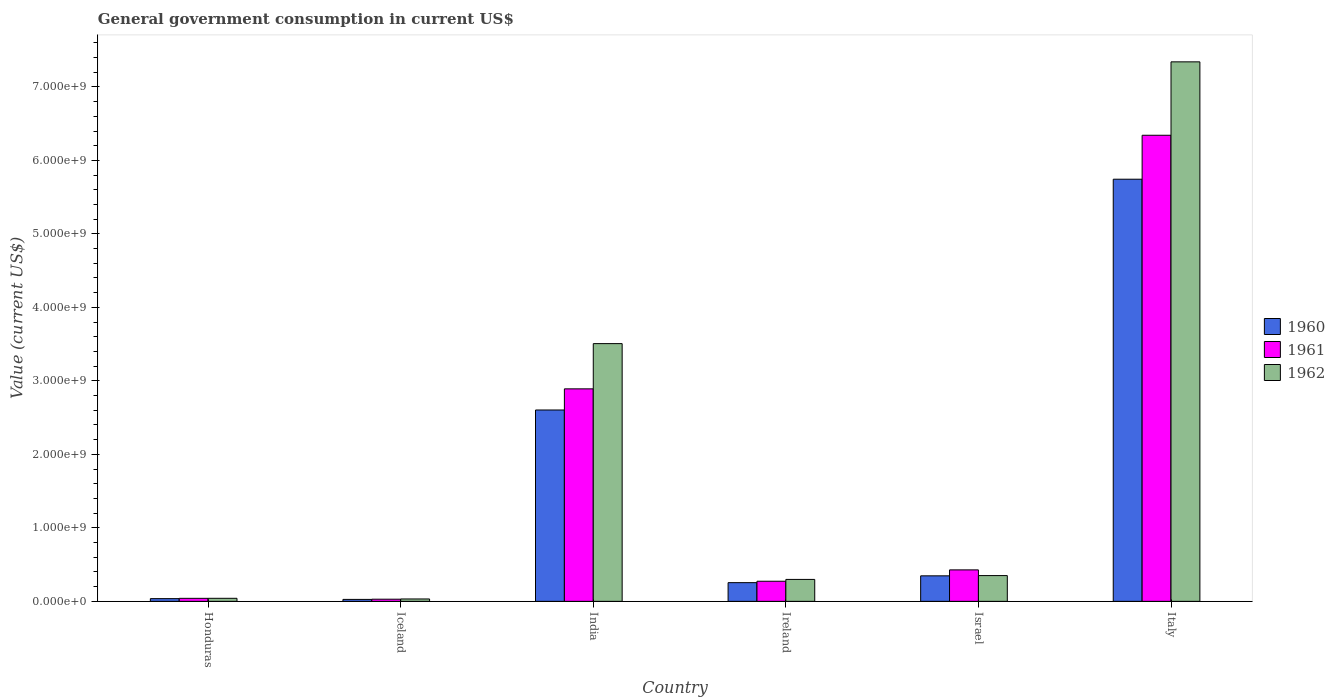How many different coloured bars are there?
Your answer should be very brief. 3. Are the number of bars on each tick of the X-axis equal?
Make the answer very short. Yes. How many bars are there on the 6th tick from the left?
Your answer should be very brief. 3. What is the label of the 4th group of bars from the left?
Provide a short and direct response. Ireland. In how many cases, is the number of bars for a given country not equal to the number of legend labels?
Offer a very short reply. 0. What is the government conusmption in 1961 in Iceland?
Give a very brief answer. 2.95e+07. Across all countries, what is the maximum government conusmption in 1961?
Your answer should be compact. 6.34e+09. Across all countries, what is the minimum government conusmption in 1960?
Make the answer very short. 2.68e+07. In which country was the government conusmption in 1960 maximum?
Your answer should be very brief. Italy. In which country was the government conusmption in 1962 minimum?
Give a very brief answer. Iceland. What is the total government conusmption in 1960 in the graph?
Offer a very short reply. 9.01e+09. What is the difference between the government conusmption in 1961 in Honduras and that in Israel?
Your answer should be very brief. -3.87e+08. What is the difference between the government conusmption in 1961 in India and the government conusmption in 1962 in Italy?
Ensure brevity in your answer.  -4.45e+09. What is the average government conusmption in 1960 per country?
Ensure brevity in your answer.  1.50e+09. What is the difference between the government conusmption of/in 1962 and government conusmption of/in 1961 in India?
Your answer should be very brief. 6.15e+08. In how many countries, is the government conusmption in 1961 greater than 2800000000 US$?
Give a very brief answer. 2. What is the ratio of the government conusmption in 1962 in Iceland to that in Italy?
Offer a terse response. 0. Is the difference between the government conusmption in 1962 in Honduras and India greater than the difference between the government conusmption in 1961 in Honduras and India?
Your answer should be compact. No. What is the difference between the highest and the second highest government conusmption in 1961?
Keep it short and to the point. -3.45e+09. What is the difference between the highest and the lowest government conusmption in 1962?
Keep it short and to the point. 7.31e+09. Is the sum of the government conusmption in 1960 in Israel and Italy greater than the maximum government conusmption in 1961 across all countries?
Your answer should be very brief. No. What does the 2nd bar from the left in Honduras represents?
Provide a succinct answer. 1961. Are all the bars in the graph horizontal?
Provide a short and direct response. No. How many countries are there in the graph?
Give a very brief answer. 6. What is the difference between two consecutive major ticks on the Y-axis?
Offer a terse response. 1.00e+09. Are the values on the major ticks of Y-axis written in scientific E-notation?
Your answer should be compact. Yes. Where does the legend appear in the graph?
Your response must be concise. Center right. What is the title of the graph?
Provide a succinct answer. General government consumption in current US$. What is the label or title of the X-axis?
Provide a short and direct response. Country. What is the label or title of the Y-axis?
Keep it short and to the point. Value (current US$). What is the Value (current US$) in 1960 in Honduras?
Offer a very short reply. 3.72e+07. What is the Value (current US$) of 1961 in Honduras?
Provide a succinct answer. 4.10e+07. What is the Value (current US$) of 1962 in Honduras?
Your response must be concise. 4.16e+07. What is the Value (current US$) of 1960 in Iceland?
Keep it short and to the point. 2.68e+07. What is the Value (current US$) in 1961 in Iceland?
Your answer should be very brief. 2.95e+07. What is the Value (current US$) of 1962 in Iceland?
Your answer should be very brief. 3.25e+07. What is the Value (current US$) of 1960 in India?
Give a very brief answer. 2.60e+09. What is the Value (current US$) of 1961 in India?
Your response must be concise. 2.89e+09. What is the Value (current US$) in 1962 in India?
Ensure brevity in your answer.  3.51e+09. What is the Value (current US$) in 1960 in Ireland?
Offer a terse response. 2.55e+08. What is the Value (current US$) in 1961 in Ireland?
Your response must be concise. 2.74e+08. What is the Value (current US$) in 1962 in Ireland?
Keep it short and to the point. 2.99e+08. What is the Value (current US$) in 1960 in Israel?
Keep it short and to the point. 3.47e+08. What is the Value (current US$) in 1961 in Israel?
Provide a succinct answer. 4.28e+08. What is the Value (current US$) of 1962 in Israel?
Provide a succinct answer. 3.51e+08. What is the Value (current US$) of 1960 in Italy?
Provide a succinct answer. 5.74e+09. What is the Value (current US$) of 1961 in Italy?
Your answer should be compact. 6.34e+09. What is the Value (current US$) in 1962 in Italy?
Offer a terse response. 7.34e+09. Across all countries, what is the maximum Value (current US$) of 1960?
Offer a terse response. 5.74e+09. Across all countries, what is the maximum Value (current US$) of 1961?
Make the answer very short. 6.34e+09. Across all countries, what is the maximum Value (current US$) in 1962?
Make the answer very short. 7.34e+09. Across all countries, what is the minimum Value (current US$) in 1960?
Your response must be concise. 2.68e+07. Across all countries, what is the minimum Value (current US$) of 1961?
Make the answer very short. 2.95e+07. Across all countries, what is the minimum Value (current US$) of 1962?
Offer a very short reply. 3.25e+07. What is the total Value (current US$) of 1960 in the graph?
Ensure brevity in your answer.  9.01e+09. What is the total Value (current US$) in 1961 in the graph?
Offer a very short reply. 1.00e+1. What is the total Value (current US$) in 1962 in the graph?
Offer a terse response. 1.16e+1. What is the difference between the Value (current US$) in 1960 in Honduras and that in Iceland?
Make the answer very short. 1.04e+07. What is the difference between the Value (current US$) of 1961 in Honduras and that in Iceland?
Provide a short and direct response. 1.15e+07. What is the difference between the Value (current US$) in 1962 in Honduras and that in Iceland?
Provide a short and direct response. 9.12e+06. What is the difference between the Value (current US$) of 1960 in Honduras and that in India?
Ensure brevity in your answer.  -2.57e+09. What is the difference between the Value (current US$) in 1961 in Honduras and that in India?
Offer a very short reply. -2.85e+09. What is the difference between the Value (current US$) of 1962 in Honduras and that in India?
Give a very brief answer. -3.47e+09. What is the difference between the Value (current US$) in 1960 in Honduras and that in Ireland?
Provide a succinct answer. -2.17e+08. What is the difference between the Value (current US$) of 1961 in Honduras and that in Ireland?
Provide a succinct answer. -2.33e+08. What is the difference between the Value (current US$) in 1962 in Honduras and that in Ireland?
Ensure brevity in your answer.  -2.57e+08. What is the difference between the Value (current US$) of 1960 in Honduras and that in Israel?
Your response must be concise. -3.10e+08. What is the difference between the Value (current US$) of 1961 in Honduras and that in Israel?
Keep it short and to the point. -3.87e+08. What is the difference between the Value (current US$) in 1962 in Honduras and that in Israel?
Your answer should be very brief. -3.09e+08. What is the difference between the Value (current US$) of 1960 in Honduras and that in Italy?
Make the answer very short. -5.71e+09. What is the difference between the Value (current US$) of 1961 in Honduras and that in Italy?
Make the answer very short. -6.30e+09. What is the difference between the Value (current US$) in 1962 in Honduras and that in Italy?
Offer a very short reply. -7.30e+09. What is the difference between the Value (current US$) in 1960 in Iceland and that in India?
Ensure brevity in your answer.  -2.58e+09. What is the difference between the Value (current US$) of 1961 in Iceland and that in India?
Keep it short and to the point. -2.86e+09. What is the difference between the Value (current US$) of 1962 in Iceland and that in India?
Ensure brevity in your answer.  -3.47e+09. What is the difference between the Value (current US$) of 1960 in Iceland and that in Ireland?
Your answer should be very brief. -2.28e+08. What is the difference between the Value (current US$) of 1961 in Iceland and that in Ireland?
Provide a short and direct response. -2.44e+08. What is the difference between the Value (current US$) in 1962 in Iceland and that in Ireland?
Your answer should be compact. -2.66e+08. What is the difference between the Value (current US$) of 1960 in Iceland and that in Israel?
Your answer should be compact. -3.20e+08. What is the difference between the Value (current US$) of 1961 in Iceland and that in Israel?
Provide a short and direct response. -3.99e+08. What is the difference between the Value (current US$) of 1962 in Iceland and that in Israel?
Your answer should be compact. -3.18e+08. What is the difference between the Value (current US$) of 1960 in Iceland and that in Italy?
Ensure brevity in your answer.  -5.72e+09. What is the difference between the Value (current US$) of 1961 in Iceland and that in Italy?
Offer a terse response. -6.31e+09. What is the difference between the Value (current US$) in 1962 in Iceland and that in Italy?
Offer a terse response. -7.31e+09. What is the difference between the Value (current US$) in 1960 in India and that in Ireland?
Your answer should be compact. 2.35e+09. What is the difference between the Value (current US$) of 1961 in India and that in Ireland?
Make the answer very short. 2.62e+09. What is the difference between the Value (current US$) in 1962 in India and that in Ireland?
Your answer should be very brief. 3.21e+09. What is the difference between the Value (current US$) of 1960 in India and that in Israel?
Offer a terse response. 2.26e+09. What is the difference between the Value (current US$) in 1961 in India and that in Israel?
Your answer should be very brief. 2.46e+09. What is the difference between the Value (current US$) of 1962 in India and that in Israel?
Your answer should be very brief. 3.16e+09. What is the difference between the Value (current US$) in 1960 in India and that in Italy?
Your answer should be compact. -3.14e+09. What is the difference between the Value (current US$) of 1961 in India and that in Italy?
Your answer should be very brief. -3.45e+09. What is the difference between the Value (current US$) of 1962 in India and that in Italy?
Ensure brevity in your answer.  -3.83e+09. What is the difference between the Value (current US$) in 1960 in Ireland and that in Israel?
Make the answer very short. -9.27e+07. What is the difference between the Value (current US$) in 1961 in Ireland and that in Israel?
Offer a terse response. -1.55e+08. What is the difference between the Value (current US$) in 1962 in Ireland and that in Israel?
Your response must be concise. -5.21e+07. What is the difference between the Value (current US$) in 1960 in Ireland and that in Italy?
Your answer should be compact. -5.49e+09. What is the difference between the Value (current US$) in 1961 in Ireland and that in Italy?
Offer a terse response. -6.07e+09. What is the difference between the Value (current US$) of 1962 in Ireland and that in Italy?
Your response must be concise. -7.04e+09. What is the difference between the Value (current US$) of 1960 in Israel and that in Italy?
Keep it short and to the point. -5.40e+09. What is the difference between the Value (current US$) of 1961 in Israel and that in Italy?
Give a very brief answer. -5.91e+09. What is the difference between the Value (current US$) in 1962 in Israel and that in Italy?
Ensure brevity in your answer.  -6.99e+09. What is the difference between the Value (current US$) in 1960 in Honduras and the Value (current US$) in 1961 in Iceland?
Provide a succinct answer. 7.62e+06. What is the difference between the Value (current US$) of 1960 in Honduras and the Value (current US$) of 1962 in Iceland?
Your response must be concise. 4.62e+06. What is the difference between the Value (current US$) of 1961 in Honduras and the Value (current US$) of 1962 in Iceland?
Your response must be concise. 8.52e+06. What is the difference between the Value (current US$) of 1960 in Honduras and the Value (current US$) of 1961 in India?
Give a very brief answer. -2.85e+09. What is the difference between the Value (current US$) of 1960 in Honduras and the Value (current US$) of 1962 in India?
Provide a short and direct response. -3.47e+09. What is the difference between the Value (current US$) of 1961 in Honduras and the Value (current US$) of 1962 in India?
Offer a terse response. -3.47e+09. What is the difference between the Value (current US$) of 1960 in Honduras and the Value (current US$) of 1961 in Ireland?
Ensure brevity in your answer.  -2.37e+08. What is the difference between the Value (current US$) in 1960 in Honduras and the Value (current US$) in 1962 in Ireland?
Keep it short and to the point. -2.61e+08. What is the difference between the Value (current US$) in 1961 in Honduras and the Value (current US$) in 1962 in Ireland?
Your answer should be very brief. -2.58e+08. What is the difference between the Value (current US$) of 1960 in Honduras and the Value (current US$) of 1961 in Israel?
Ensure brevity in your answer.  -3.91e+08. What is the difference between the Value (current US$) in 1960 in Honduras and the Value (current US$) in 1962 in Israel?
Offer a very short reply. -3.14e+08. What is the difference between the Value (current US$) of 1961 in Honduras and the Value (current US$) of 1962 in Israel?
Provide a succinct answer. -3.10e+08. What is the difference between the Value (current US$) in 1960 in Honduras and the Value (current US$) in 1961 in Italy?
Your response must be concise. -6.31e+09. What is the difference between the Value (current US$) in 1960 in Honduras and the Value (current US$) in 1962 in Italy?
Ensure brevity in your answer.  -7.30e+09. What is the difference between the Value (current US$) in 1961 in Honduras and the Value (current US$) in 1962 in Italy?
Give a very brief answer. -7.30e+09. What is the difference between the Value (current US$) of 1960 in Iceland and the Value (current US$) of 1961 in India?
Give a very brief answer. -2.86e+09. What is the difference between the Value (current US$) in 1960 in Iceland and the Value (current US$) in 1962 in India?
Ensure brevity in your answer.  -3.48e+09. What is the difference between the Value (current US$) in 1961 in Iceland and the Value (current US$) in 1962 in India?
Your response must be concise. -3.48e+09. What is the difference between the Value (current US$) in 1960 in Iceland and the Value (current US$) in 1961 in Ireland?
Keep it short and to the point. -2.47e+08. What is the difference between the Value (current US$) in 1960 in Iceland and the Value (current US$) in 1962 in Ireland?
Provide a succinct answer. -2.72e+08. What is the difference between the Value (current US$) in 1961 in Iceland and the Value (current US$) in 1962 in Ireland?
Keep it short and to the point. -2.69e+08. What is the difference between the Value (current US$) in 1960 in Iceland and the Value (current US$) in 1961 in Israel?
Offer a terse response. -4.02e+08. What is the difference between the Value (current US$) of 1960 in Iceland and the Value (current US$) of 1962 in Israel?
Offer a very short reply. -3.24e+08. What is the difference between the Value (current US$) in 1961 in Iceland and the Value (current US$) in 1962 in Israel?
Your answer should be compact. -3.21e+08. What is the difference between the Value (current US$) of 1960 in Iceland and the Value (current US$) of 1961 in Italy?
Your response must be concise. -6.32e+09. What is the difference between the Value (current US$) of 1960 in Iceland and the Value (current US$) of 1962 in Italy?
Provide a short and direct response. -7.31e+09. What is the difference between the Value (current US$) of 1961 in Iceland and the Value (current US$) of 1962 in Italy?
Offer a very short reply. -7.31e+09. What is the difference between the Value (current US$) of 1960 in India and the Value (current US$) of 1961 in Ireland?
Your answer should be compact. 2.33e+09. What is the difference between the Value (current US$) in 1960 in India and the Value (current US$) in 1962 in Ireland?
Offer a terse response. 2.31e+09. What is the difference between the Value (current US$) of 1961 in India and the Value (current US$) of 1962 in Ireland?
Your answer should be compact. 2.59e+09. What is the difference between the Value (current US$) in 1960 in India and the Value (current US$) in 1961 in Israel?
Make the answer very short. 2.18e+09. What is the difference between the Value (current US$) in 1960 in India and the Value (current US$) in 1962 in Israel?
Offer a very short reply. 2.25e+09. What is the difference between the Value (current US$) of 1961 in India and the Value (current US$) of 1962 in Israel?
Provide a succinct answer. 2.54e+09. What is the difference between the Value (current US$) in 1960 in India and the Value (current US$) in 1961 in Italy?
Keep it short and to the point. -3.74e+09. What is the difference between the Value (current US$) in 1960 in India and the Value (current US$) in 1962 in Italy?
Provide a succinct answer. -4.74e+09. What is the difference between the Value (current US$) of 1961 in India and the Value (current US$) of 1962 in Italy?
Keep it short and to the point. -4.45e+09. What is the difference between the Value (current US$) in 1960 in Ireland and the Value (current US$) in 1961 in Israel?
Your answer should be compact. -1.74e+08. What is the difference between the Value (current US$) of 1960 in Ireland and the Value (current US$) of 1962 in Israel?
Your answer should be very brief. -9.61e+07. What is the difference between the Value (current US$) of 1961 in Ireland and the Value (current US$) of 1962 in Israel?
Give a very brief answer. -7.70e+07. What is the difference between the Value (current US$) of 1960 in Ireland and the Value (current US$) of 1961 in Italy?
Offer a very short reply. -6.09e+09. What is the difference between the Value (current US$) in 1960 in Ireland and the Value (current US$) in 1962 in Italy?
Offer a terse response. -7.09e+09. What is the difference between the Value (current US$) in 1961 in Ireland and the Value (current US$) in 1962 in Italy?
Make the answer very short. -7.07e+09. What is the difference between the Value (current US$) in 1960 in Israel and the Value (current US$) in 1961 in Italy?
Your response must be concise. -6.00e+09. What is the difference between the Value (current US$) in 1960 in Israel and the Value (current US$) in 1962 in Italy?
Offer a very short reply. -6.99e+09. What is the difference between the Value (current US$) in 1961 in Israel and the Value (current US$) in 1962 in Italy?
Ensure brevity in your answer.  -6.91e+09. What is the average Value (current US$) of 1960 per country?
Offer a very short reply. 1.50e+09. What is the average Value (current US$) in 1961 per country?
Keep it short and to the point. 1.67e+09. What is the average Value (current US$) in 1962 per country?
Provide a succinct answer. 1.93e+09. What is the difference between the Value (current US$) of 1960 and Value (current US$) of 1961 in Honduras?
Ensure brevity in your answer.  -3.90e+06. What is the difference between the Value (current US$) in 1960 and Value (current US$) in 1962 in Honduras?
Your answer should be very brief. -4.50e+06. What is the difference between the Value (current US$) of 1961 and Value (current US$) of 1962 in Honduras?
Keep it short and to the point. -6.00e+05. What is the difference between the Value (current US$) of 1960 and Value (current US$) of 1961 in Iceland?
Provide a short and direct response. -2.77e+06. What is the difference between the Value (current US$) of 1960 and Value (current US$) of 1962 in Iceland?
Offer a terse response. -5.77e+06. What is the difference between the Value (current US$) in 1961 and Value (current US$) in 1962 in Iceland?
Ensure brevity in your answer.  -3.00e+06. What is the difference between the Value (current US$) of 1960 and Value (current US$) of 1961 in India?
Ensure brevity in your answer.  -2.88e+08. What is the difference between the Value (current US$) in 1960 and Value (current US$) in 1962 in India?
Make the answer very short. -9.03e+08. What is the difference between the Value (current US$) of 1961 and Value (current US$) of 1962 in India?
Ensure brevity in your answer.  -6.15e+08. What is the difference between the Value (current US$) of 1960 and Value (current US$) of 1961 in Ireland?
Provide a succinct answer. -1.91e+07. What is the difference between the Value (current US$) of 1960 and Value (current US$) of 1962 in Ireland?
Offer a very short reply. -4.40e+07. What is the difference between the Value (current US$) of 1961 and Value (current US$) of 1962 in Ireland?
Your response must be concise. -2.49e+07. What is the difference between the Value (current US$) of 1960 and Value (current US$) of 1961 in Israel?
Keep it short and to the point. -8.11e+07. What is the difference between the Value (current US$) of 1960 and Value (current US$) of 1962 in Israel?
Provide a short and direct response. -3.47e+06. What is the difference between the Value (current US$) in 1961 and Value (current US$) in 1962 in Israel?
Provide a short and direct response. 7.76e+07. What is the difference between the Value (current US$) in 1960 and Value (current US$) in 1961 in Italy?
Provide a succinct answer. -5.98e+08. What is the difference between the Value (current US$) of 1960 and Value (current US$) of 1962 in Italy?
Keep it short and to the point. -1.60e+09. What is the difference between the Value (current US$) of 1961 and Value (current US$) of 1962 in Italy?
Provide a succinct answer. -9.99e+08. What is the ratio of the Value (current US$) of 1960 in Honduras to that in Iceland?
Your answer should be very brief. 1.39. What is the ratio of the Value (current US$) in 1961 in Honduras to that in Iceland?
Keep it short and to the point. 1.39. What is the ratio of the Value (current US$) in 1962 in Honduras to that in Iceland?
Give a very brief answer. 1.28. What is the ratio of the Value (current US$) in 1960 in Honduras to that in India?
Give a very brief answer. 0.01. What is the ratio of the Value (current US$) in 1961 in Honduras to that in India?
Your answer should be compact. 0.01. What is the ratio of the Value (current US$) in 1962 in Honduras to that in India?
Your answer should be very brief. 0.01. What is the ratio of the Value (current US$) in 1960 in Honduras to that in Ireland?
Your answer should be very brief. 0.15. What is the ratio of the Value (current US$) in 1962 in Honduras to that in Ireland?
Your response must be concise. 0.14. What is the ratio of the Value (current US$) of 1960 in Honduras to that in Israel?
Your response must be concise. 0.11. What is the ratio of the Value (current US$) of 1961 in Honduras to that in Israel?
Provide a succinct answer. 0.1. What is the ratio of the Value (current US$) in 1962 in Honduras to that in Israel?
Keep it short and to the point. 0.12. What is the ratio of the Value (current US$) in 1960 in Honduras to that in Italy?
Provide a short and direct response. 0.01. What is the ratio of the Value (current US$) of 1961 in Honduras to that in Italy?
Ensure brevity in your answer.  0.01. What is the ratio of the Value (current US$) in 1962 in Honduras to that in Italy?
Offer a terse response. 0.01. What is the ratio of the Value (current US$) of 1960 in Iceland to that in India?
Offer a terse response. 0.01. What is the ratio of the Value (current US$) of 1961 in Iceland to that in India?
Offer a very short reply. 0.01. What is the ratio of the Value (current US$) in 1962 in Iceland to that in India?
Offer a very short reply. 0.01. What is the ratio of the Value (current US$) of 1960 in Iceland to that in Ireland?
Keep it short and to the point. 0.11. What is the ratio of the Value (current US$) in 1961 in Iceland to that in Ireland?
Provide a short and direct response. 0.11. What is the ratio of the Value (current US$) in 1962 in Iceland to that in Ireland?
Your answer should be very brief. 0.11. What is the ratio of the Value (current US$) in 1960 in Iceland to that in Israel?
Make the answer very short. 0.08. What is the ratio of the Value (current US$) in 1961 in Iceland to that in Israel?
Make the answer very short. 0.07. What is the ratio of the Value (current US$) of 1962 in Iceland to that in Israel?
Ensure brevity in your answer.  0.09. What is the ratio of the Value (current US$) of 1960 in Iceland to that in Italy?
Give a very brief answer. 0. What is the ratio of the Value (current US$) of 1961 in Iceland to that in Italy?
Give a very brief answer. 0. What is the ratio of the Value (current US$) of 1962 in Iceland to that in Italy?
Your answer should be compact. 0. What is the ratio of the Value (current US$) of 1960 in India to that in Ireland?
Give a very brief answer. 10.23. What is the ratio of the Value (current US$) of 1961 in India to that in Ireland?
Make the answer very short. 10.57. What is the ratio of the Value (current US$) of 1962 in India to that in Ireland?
Give a very brief answer. 11.75. What is the ratio of the Value (current US$) in 1960 in India to that in Israel?
Your answer should be compact. 7.5. What is the ratio of the Value (current US$) in 1961 in India to that in Israel?
Offer a very short reply. 6.75. What is the ratio of the Value (current US$) in 1962 in India to that in Israel?
Provide a succinct answer. 10. What is the ratio of the Value (current US$) of 1960 in India to that in Italy?
Offer a terse response. 0.45. What is the ratio of the Value (current US$) in 1961 in India to that in Italy?
Your answer should be compact. 0.46. What is the ratio of the Value (current US$) of 1962 in India to that in Italy?
Give a very brief answer. 0.48. What is the ratio of the Value (current US$) in 1960 in Ireland to that in Israel?
Offer a very short reply. 0.73. What is the ratio of the Value (current US$) in 1961 in Ireland to that in Israel?
Ensure brevity in your answer.  0.64. What is the ratio of the Value (current US$) in 1962 in Ireland to that in Israel?
Your answer should be very brief. 0.85. What is the ratio of the Value (current US$) in 1960 in Ireland to that in Italy?
Your answer should be compact. 0.04. What is the ratio of the Value (current US$) in 1961 in Ireland to that in Italy?
Provide a succinct answer. 0.04. What is the ratio of the Value (current US$) in 1962 in Ireland to that in Italy?
Your answer should be very brief. 0.04. What is the ratio of the Value (current US$) of 1960 in Israel to that in Italy?
Offer a terse response. 0.06. What is the ratio of the Value (current US$) of 1961 in Israel to that in Italy?
Your answer should be compact. 0.07. What is the ratio of the Value (current US$) of 1962 in Israel to that in Italy?
Your response must be concise. 0.05. What is the difference between the highest and the second highest Value (current US$) in 1960?
Provide a succinct answer. 3.14e+09. What is the difference between the highest and the second highest Value (current US$) in 1961?
Keep it short and to the point. 3.45e+09. What is the difference between the highest and the second highest Value (current US$) in 1962?
Your answer should be compact. 3.83e+09. What is the difference between the highest and the lowest Value (current US$) of 1960?
Provide a succinct answer. 5.72e+09. What is the difference between the highest and the lowest Value (current US$) in 1961?
Make the answer very short. 6.31e+09. What is the difference between the highest and the lowest Value (current US$) in 1962?
Your answer should be very brief. 7.31e+09. 